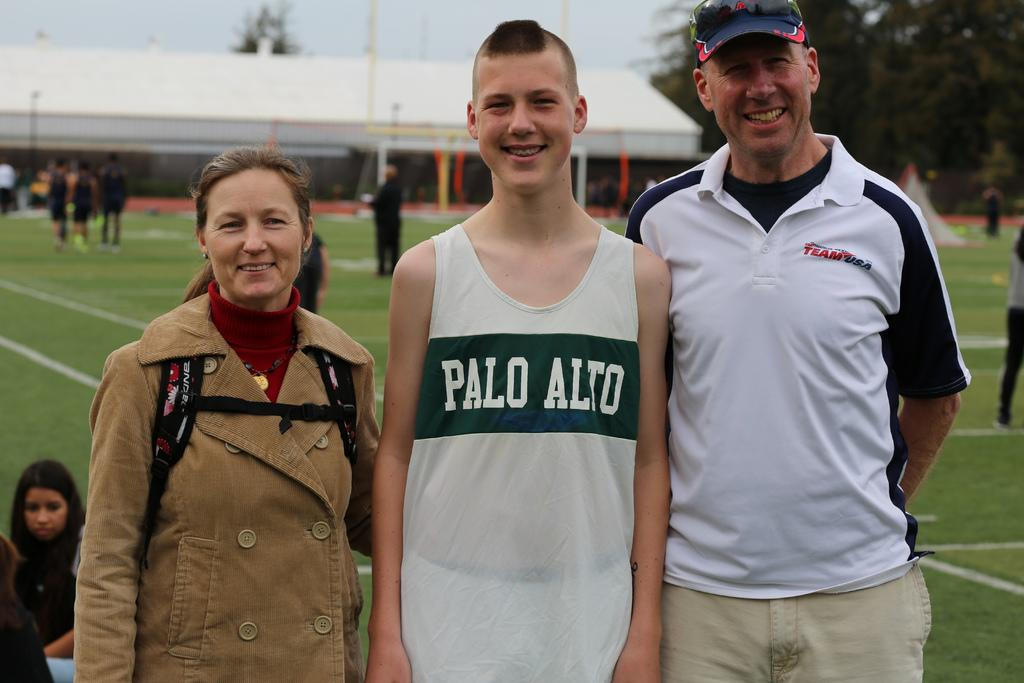Provide a one-sentence caption for the provided image. A boy wearing a Palo Alto Jersey stands with his parents and smiles. 